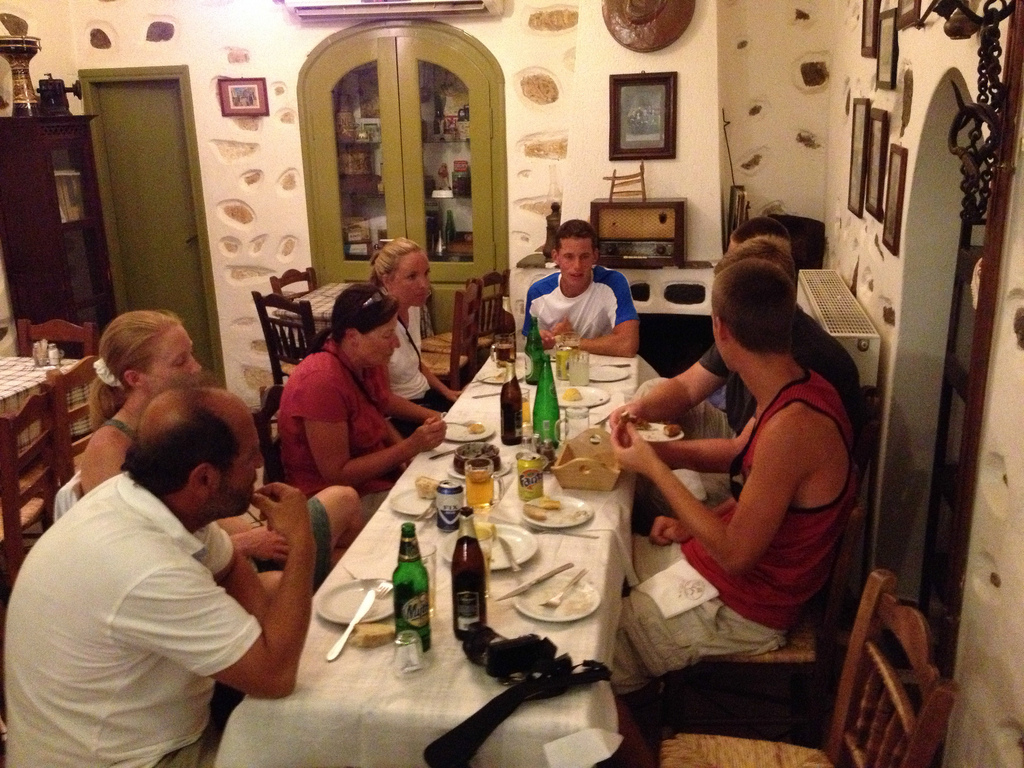Is there any fork to the right of the napkin in the picture? No visible forks are placed to the right of the napkin, illustrating the table's arrangement. 